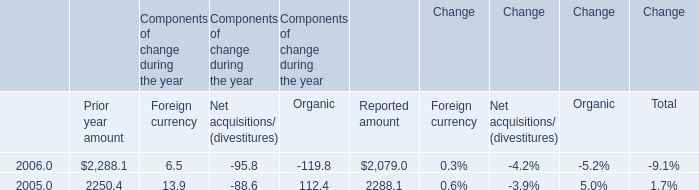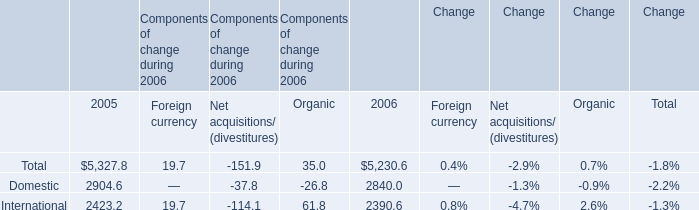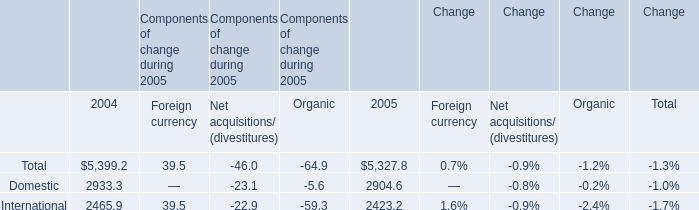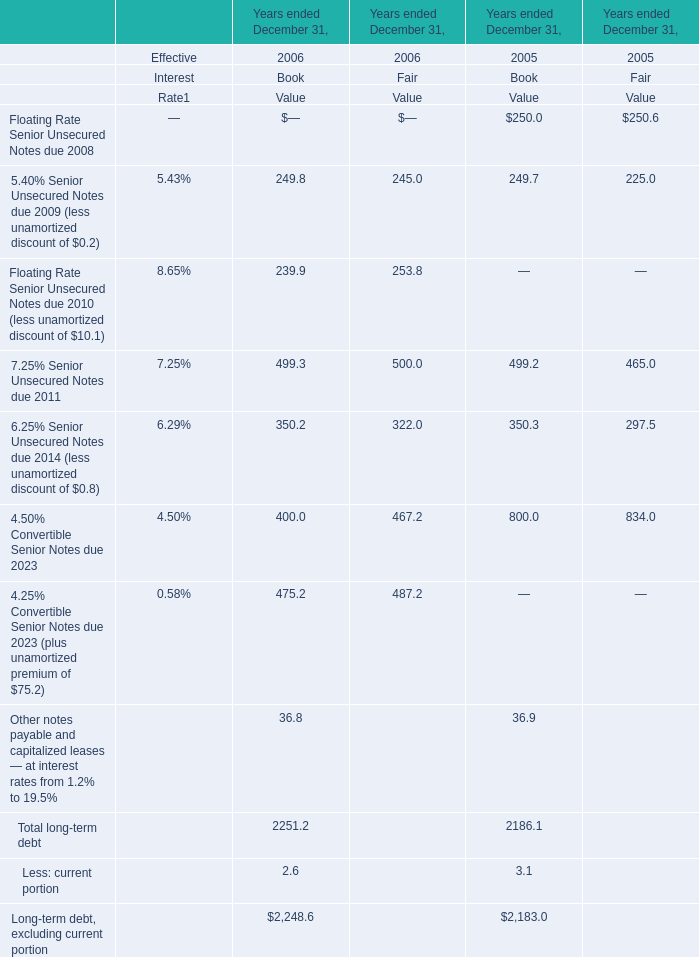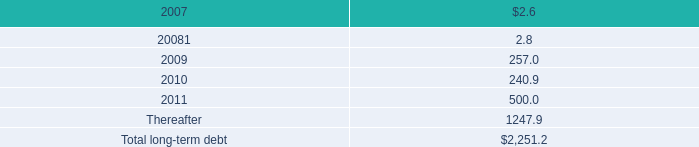What is the increasing rate of the Book Value of the total long-term debt between 2005 and 2006? 
Computations: ((2251.2 - 2186.1) / 2186.1)
Answer: 0.02978. 